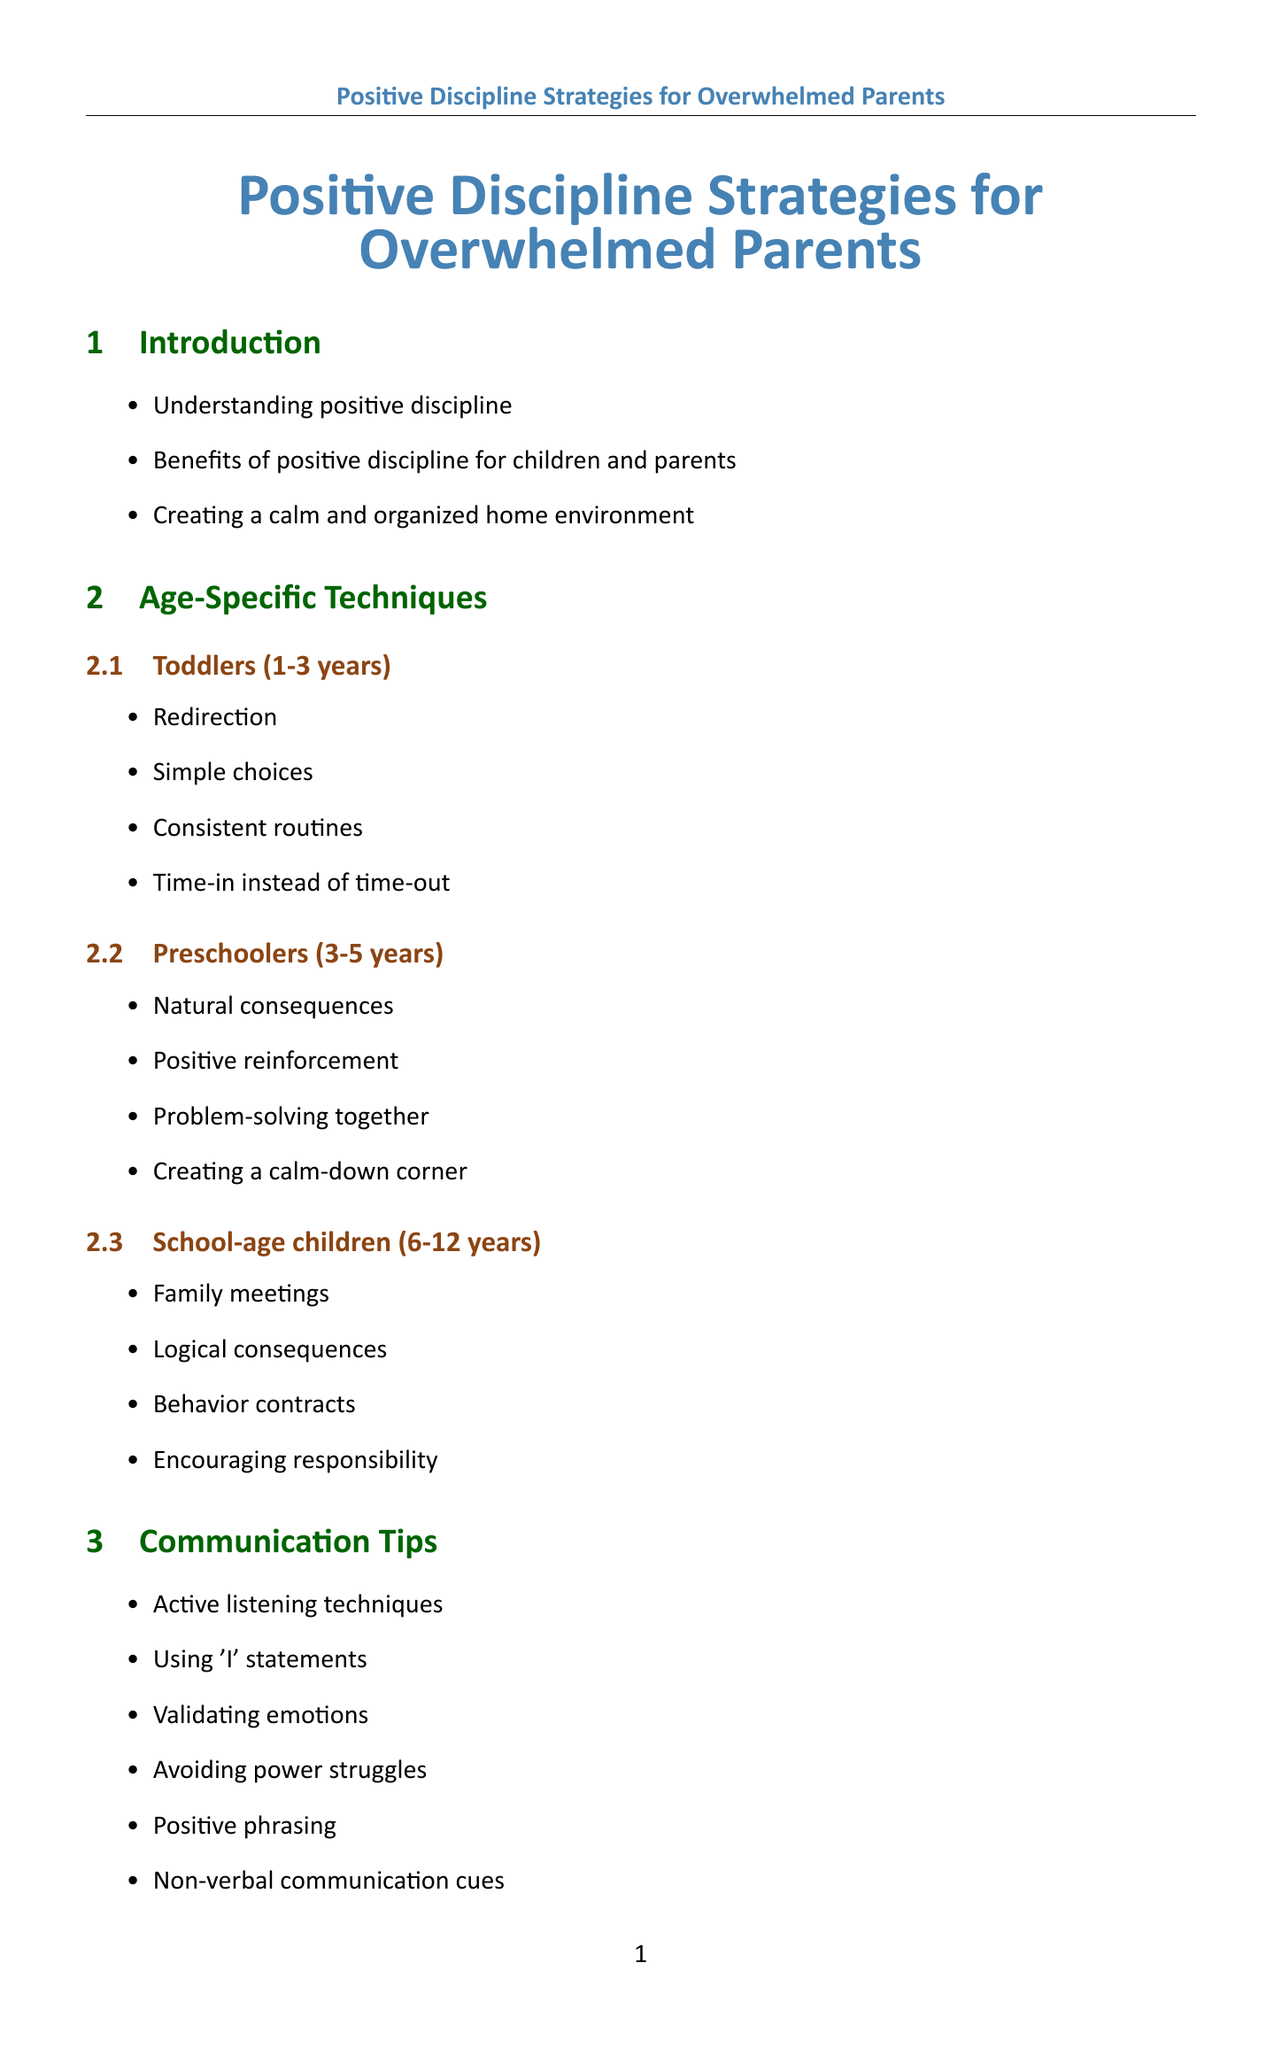What are the benefits of positive discipline? The document lists the benefits of positive discipline for both children and parents.
Answer: Benefits of positive discipline for children and parents What techniques are suggested for toddlers? The document provides age-specific techniques, including those for toddlers aged 1-3 years.
Answer: Redirection, Simple choices, Consistent routines, Time-in instead of time-out What are the communication tips provided? The section on communication tips outlines methods for effective communication with children.
Answer: Active listening techniques, Using 'I' statements, Validating emotions, Avoiding power struggles, Positive phrasing, Non-verbal communication cues What is the STAR method? The problem-solving methods section mentions the STAR method as one of the techniques.
Answer: Stop, Think, Act, Review How many age groups are outlined for techniques? The Age-Specific Techniques section categorizes techniques into three age groups.
Answer: Three age groups What should parents do to manage screen time? One of the implementation strategies in the document specifically addresses screen time management.
Answer: Managing screen time What is one self-care technique for overwhelmed parents? The self-care section lists various techniques for parents to manage their stress.
Answer: Stress management techniques Which book is recommended for communication? The Resources section includes books that could help improve parent-child communication strategies.
Answer: "How to Talk So Kids Will Listen & Listen So Kids Will Talk" by Adele Faber and Elaine Mazlish What is included in the resource section? The document lists various types of resources including books, websites, and apps for parents.
Answer: Books, Websites, Apps 